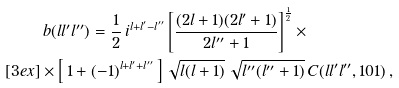<formula> <loc_0><loc_0><loc_500><loc_500>& \, b ( l l ^ { \prime } l ^ { \prime \prime } ) = \frac { 1 } { 2 } \, i ^ { l + l ^ { \prime } - l ^ { \prime \prime } } \left [ \frac { ( 2 l + 1 ) ( 2 l ^ { \prime } + 1 ) } { 2 l ^ { \prime \prime } + 1 } \right ] ^ { \frac { 1 } { 2 } } \times \\ [ 3 e x ] & \times \left [ \, 1 + ( - 1 ) ^ { l + l ^ { \prime } + l ^ { \prime \prime } } \, \right ] \sqrt { l ( l + 1 ) } \, \sqrt { l ^ { \prime \prime } ( l ^ { \prime \prime } + 1 ) } \, C ( l l ^ { \prime } l ^ { \prime \prime } , 1 0 1 ) \, ,</formula> 